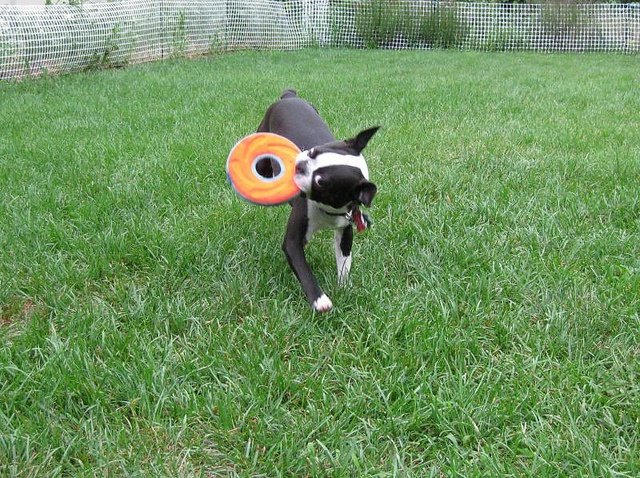Describe the objects in this image and their specific colors. I can see dog in lightgray, black, gray, white, and darkgray tones and frisbee in lightgray, orange, gold, and salmon tones in this image. 